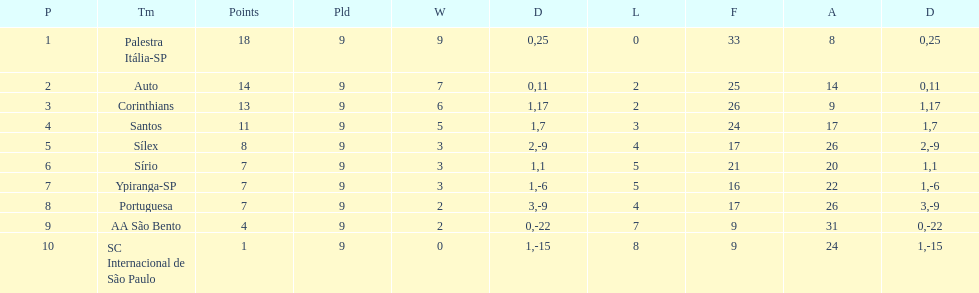In 1926 brazilian football, how many teams scored above 10 points in the season? 4. 